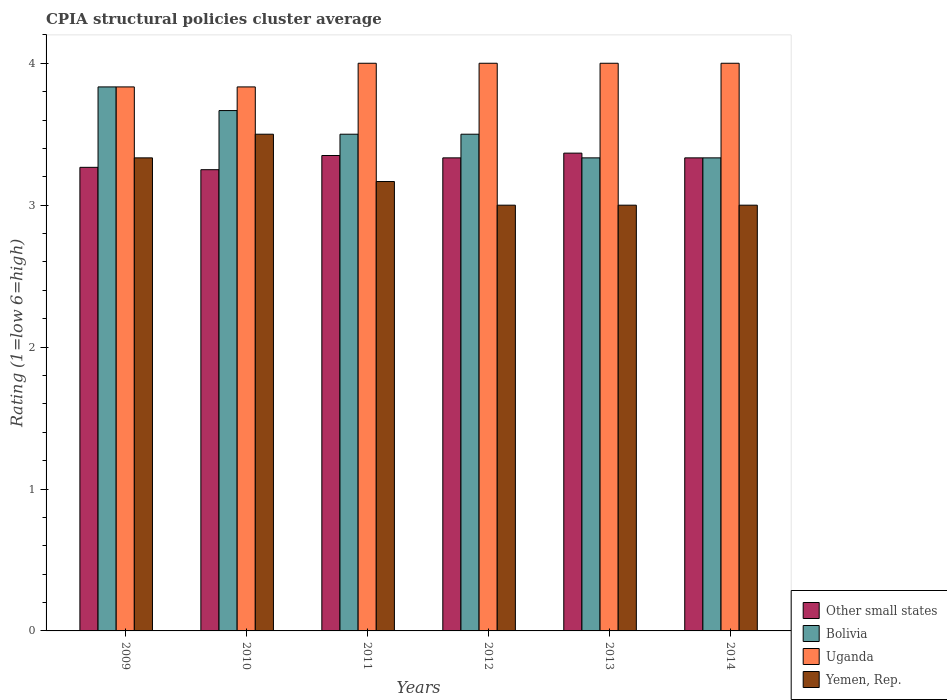How many different coloured bars are there?
Offer a very short reply. 4. Are the number of bars on each tick of the X-axis equal?
Your response must be concise. Yes. How many bars are there on the 1st tick from the right?
Offer a terse response. 4. What is the label of the 4th group of bars from the left?
Keep it short and to the point. 2012. In how many cases, is the number of bars for a given year not equal to the number of legend labels?
Provide a short and direct response. 0. What is the CPIA rating in Uganda in 2014?
Your answer should be compact. 4. Across all years, what is the maximum CPIA rating in Other small states?
Keep it short and to the point. 3.37. Across all years, what is the minimum CPIA rating in Bolivia?
Your answer should be very brief. 3.33. In which year was the CPIA rating in Bolivia minimum?
Offer a very short reply. 2014. What is the total CPIA rating in Uganda in the graph?
Your response must be concise. 23.67. What is the difference between the CPIA rating in Bolivia in 2011 and that in 2013?
Provide a succinct answer. 0.17. What is the difference between the CPIA rating in Uganda in 2010 and the CPIA rating in Yemen, Rep. in 2014?
Make the answer very short. 0.83. What is the average CPIA rating in Uganda per year?
Provide a short and direct response. 3.94. In the year 2009, what is the difference between the CPIA rating in Uganda and CPIA rating in Other small states?
Offer a terse response. 0.57. What is the ratio of the CPIA rating in Bolivia in 2009 to that in 2010?
Keep it short and to the point. 1.05. Is the CPIA rating in Other small states in 2011 less than that in 2012?
Offer a terse response. No. Is the difference between the CPIA rating in Uganda in 2010 and 2014 greater than the difference between the CPIA rating in Other small states in 2010 and 2014?
Offer a very short reply. No. In how many years, is the CPIA rating in Yemen, Rep. greater than the average CPIA rating in Yemen, Rep. taken over all years?
Ensure brevity in your answer.  3. Is it the case that in every year, the sum of the CPIA rating in Other small states and CPIA rating in Uganda is greater than the sum of CPIA rating in Yemen, Rep. and CPIA rating in Bolivia?
Your answer should be compact. Yes. What does the 4th bar from the right in 2014 represents?
Make the answer very short. Other small states. How many bars are there?
Ensure brevity in your answer.  24. How are the legend labels stacked?
Give a very brief answer. Vertical. What is the title of the graph?
Ensure brevity in your answer.  CPIA structural policies cluster average. Does "Faeroe Islands" appear as one of the legend labels in the graph?
Make the answer very short. No. What is the label or title of the X-axis?
Make the answer very short. Years. What is the label or title of the Y-axis?
Give a very brief answer. Rating (1=low 6=high). What is the Rating (1=low 6=high) in Other small states in 2009?
Your answer should be very brief. 3.27. What is the Rating (1=low 6=high) of Bolivia in 2009?
Your answer should be compact. 3.83. What is the Rating (1=low 6=high) in Uganda in 2009?
Your response must be concise. 3.83. What is the Rating (1=low 6=high) of Yemen, Rep. in 2009?
Offer a very short reply. 3.33. What is the Rating (1=low 6=high) in Other small states in 2010?
Ensure brevity in your answer.  3.25. What is the Rating (1=low 6=high) in Bolivia in 2010?
Keep it short and to the point. 3.67. What is the Rating (1=low 6=high) of Uganda in 2010?
Make the answer very short. 3.83. What is the Rating (1=low 6=high) of Other small states in 2011?
Your answer should be very brief. 3.35. What is the Rating (1=low 6=high) in Yemen, Rep. in 2011?
Offer a terse response. 3.17. What is the Rating (1=low 6=high) of Other small states in 2012?
Provide a succinct answer. 3.33. What is the Rating (1=low 6=high) in Other small states in 2013?
Offer a very short reply. 3.37. What is the Rating (1=low 6=high) of Bolivia in 2013?
Give a very brief answer. 3.33. What is the Rating (1=low 6=high) of Yemen, Rep. in 2013?
Make the answer very short. 3. What is the Rating (1=low 6=high) in Other small states in 2014?
Ensure brevity in your answer.  3.33. What is the Rating (1=low 6=high) of Bolivia in 2014?
Your answer should be compact. 3.33. What is the Rating (1=low 6=high) in Yemen, Rep. in 2014?
Provide a succinct answer. 3. Across all years, what is the maximum Rating (1=low 6=high) in Other small states?
Make the answer very short. 3.37. Across all years, what is the maximum Rating (1=low 6=high) in Bolivia?
Ensure brevity in your answer.  3.83. Across all years, what is the maximum Rating (1=low 6=high) of Yemen, Rep.?
Your answer should be very brief. 3.5. Across all years, what is the minimum Rating (1=low 6=high) in Other small states?
Ensure brevity in your answer.  3.25. Across all years, what is the minimum Rating (1=low 6=high) in Bolivia?
Ensure brevity in your answer.  3.33. Across all years, what is the minimum Rating (1=low 6=high) in Uganda?
Your response must be concise. 3.83. What is the total Rating (1=low 6=high) of Bolivia in the graph?
Offer a very short reply. 21.17. What is the total Rating (1=low 6=high) of Uganda in the graph?
Keep it short and to the point. 23.67. What is the total Rating (1=low 6=high) in Yemen, Rep. in the graph?
Offer a very short reply. 19. What is the difference between the Rating (1=low 6=high) in Other small states in 2009 and that in 2010?
Keep it short and to the point. 0.02. What is the difference between the Rating (1=low 6=high) of Bolivia in 2009 and that in 2010?
Your answer should be very brief. 0.17. What is the difference between the Rating (1=low 6=high) of Uganda in 2009 and that in 2010?
Ensure brevity in your answer.  0. What is the difference between the Rating (1=low 6=high) in Other small states in 2009 and that in 2011?
Provide a succinct answer. -0.08. What is the difference between the Rating (1=low 6=high) in Yemen, Rep. in 2009 and that in 2011?
Your answer should be very brief. 0.17. What is the difference between the Rating (1=low 6=high) of Other small states in 2009 and that in 2012?
Make the answer very short. -0.07. What is the difference between the Rating (1=low 6=high) of Bolivia in 2009 and that in 2012?
Make the answer very short. 0.33. What is the difference between the Rating (1=low 6=high) in Other small states in 2009 and that in 2013?
Keep it short and to the point. -0.1. What is the difference between the Rating (1=low 6=high) in Yemen, Rep. in 2009 and that in 2013?
Your answer should be very brief. 0.33. What is the difference between the Rating (1=low 6=high) of Other small states in 2009 and that in 2014?
Your answer should be compact. -0.07. What is the difference between the Rating (1=low 6=high) of Bolivia in 2010 and that in 2011?
Offer a very short reply. 0.17. What is the difference between the Rating (1=low 6=high) of Uganda in 2010 and that in 2011?
Make the answer very short. -0.17. What is the difference between the Rating (1=low 6=high) of Other small states in 2010 and that in 2012?
Give a very brief answer. -0.08. What is the difference between the Rating (1=low 6=high) in Uganda in 2010 and that in 2012?
Keep it short and to the point. -0.17. What is the difference between the Rating (1=low 6=high) of Other small states in 2010 and that in 2013?
Give a very brief answer. -0.12. What is the difference between the Rating (1=low 6=high) of Other small states in 2010 and that in 2014?
Offer a terse response. -0.08. What is the difference between the Rating (1=low 6=high) in Uganda in 2010 and that in 2014?
Offer a terse response. -0.17. What is the difference between the Rating (1=low 6=high) in Yemen, Rep. in 2010 and that in 2014?
Offer a very short reply. 0.5. What is the difference between the Rating (1=low 6=high) in Other small states in 2011 and that in 2012?
Ensure brevity in your answer.  0.02. What is the difference between the Rating (1=low 6=high) of Bolivia in 2011 and that in 2012?
Your response must be concise. 0. What is the difference between the Rating (1=low 6=high) of Uganda in 2011 and that in 2012?
Provide a short and direct response. 0. What is the difference between the Rating (1=low 6=high) in Yemen, Rep. in 2011 and that in 2012?
Make the answer very short. 0.17. What is the difference between the Rating (1=low 6=high) in Other small states in 2011 and that in 2013?
Provide a succinct answer. -0.02. What is the difference between the Rating (1=low 6=high) of Bolivia in 2011 and that in 2013?
Your response must be concise. 0.17. What is the difference between the Rating (1=low 6=high) of Uganda in 2011 and that in 2013?
Offer a very short reply. 0. What is the difference between the Rating (1=low 6=high) in Yemen, Rep. in 2011 and that in 2013?
Provide a succinct answer. 0.17. What is the difference between the Rating (1=low 6=high) in Other small states in 2011 and that in 2014?
Your response must be concise. 0.02. What is the difference between the Rating (1=low 6=high) of Uganda in 2011 and that in 2014?
Offer a very short reply. 0. What is the difference between the Rating (1=low 6=high) of Yemen, Rep. in 2011 and that in 2014?
Your response must be concise. 0.17. What is the difference between the Rating (1=low 6=high) in Other small states in 2012 and that in 2013?
Make the answer very short. -0.03. What is the difference between the Rating (1=low 6=high) in Bolivia in 2012 and that in 2013?
Offer a very short reply. 0.17. What is the difference between the Rating (1=low 6=high) of Other small states in 2012 and that in 2014?
Ensure brevity in your answer.  0. What is the difference between the Rating (1=low 6=high) in Uganda in 2012 and that in 2014?
Your response must be concise. 0. What is the difference between the Rating (1=low 6=high) of Yemen, Rep. in 2012 and that in 2014?
Your response must be concise. 0. What is the difference between the Rating (1=low 6=high) in Bolivia in 2013 and that in 2014?
Your answer should be compact. 0. What is the difference between the Rating (1=low 6=high) in Uganda in 2013 and that in 2014?
Offer a very short reply. 0. What is the difference between the Rating (1=low 6=high) of Yemen, Rep. in 2013 and that in 2014?
Ensure brevity in your answer.  0. What is the difference between the Rating (1=low 6=high) in Other small states in 2009 and the Rating (1=low 6=high) in Bolivia in 2010?
Provide a short and direct response. -0.4. What is the difference between the Rating (1=low 6=high) of Other small states in 2009 and the Rating (1=low 6=high) of Uganda in 2010?
Your response must be concise. -0.57. What is the difference between the Rating (1=low 6=high) in Other small states in 2009 and the Rating (1=low 6=high) in Yemen, Rep. in 2010?
Ensure brevity in your answer.  -0.23. What is the difference between the Rating (1=low 6=high) in Bolivia in 2009 and the Rating (1=low 6=high) in Uganda in 2010?
Make the answer very short. 0. What is the difference between the Rating (1=low 6=high) in Other small states in 2009 and the Rating (1=low 6=high) in Bolivia in 2011?
Ensure brevity in your answer.  -0.23. What is the difference between the Rating (1=low 6=high) in Other small states in 2009 and the Rating (1=low 6=high) in Uganda in 2011?
Make the answer very short. -0.73. What is the difference between the Rating (1=low 6=high) in Bolivia in 2009 and the Rating (1=low 6=high) in Yemen, Rep. in 2011?
Provide a short and direct response. 0.67. What is the difference between the Rating (1=low 6=high) in Uganda in 2009 and the Rating (1=low 6=high) in Yemen, Rep. in 2011?
Offer a terse response. 0.67. What is the difference between the Rating (1=low 6=high) in Other small states in 2009 and the Rating (1=low 6=high) in Bolivia in 2012?
Ensure brevity in your answer.  -0.23. What is the difference between the Rating (1=low 6=high) in Other small states in 2009 and the Rating (1=low 6=high) in Uganda in 2012?
Your response must be concise. -0.73. What is the difference between the Rating (1=low 6=high) of Other small states in 2009 and the Rating (1=low 6=high) of Yemen, Rep. in 2012?
Your response must be concise. 0.27. What is the difference between the Rating (1=low 6=high) in Bolivia in 2009 and the Rating (1=low 6=high) in Uganda in 2012?
Offer a very short reply. -0.17. What is the difference between the Rating (1=low 6=high) of Bolivia in 2009 and the Rating (1=low 6=high) of Yemen, Rep. in 2012?
Make the answer very short. 0.83. What is the difference between the Rating (1=low 6=high) in Uganda in 2009 and the Rating (1=low 6=high) in Yemen, Rep. in 2012?
Provide a short and direct response. 0.83. What is the difference between the Rating (1=low 6=high) in Other small states in 2009 and the Rating (1=low 6=high) in Bolivia in 2013?
Provide a succinct answer. -0.07. What is the difference between the Rating (1=low 6=high) of Other small states in 2009 and the Rating (1=low 6=high) of Uganda in 2013?
Ensure brevity in your answer.  -0.73. What is the difference between the Rating (1=low 6=high) of Other small states in 2009 and the Rating (1=low 6=high) of Yemen, Rep. in 2013?
Give a very brief answer. 0.27. What is the difference between the Rating (1=low 6=high) of Uganda in 2009 and the Rating (1=low 6=high) of Yemen, Rep. in 2013?
Give a very brief answer. 0.83. What is the difference between the Rating (1=low 6=high) of Other small states in 2009 and the Rating (1=low 6=high) of Bolivia in 2014?
Your answer should be compact. -0.07. What is the difference between the Rating (1=low 6=high) of Other small states in 2009 and the Rating (1=low 6=high) of Uganda in 2014?
Ensure brevity in your answer.  -0.73. What is the difference between the Rating (1=low 6=high) in Other small states in 2009 and the Rating (1=low 6=high) in Yemen, Rep. in 2014?
Offer a very short reply. 0.27. What is the difference between the Rating (1=low 6=high) in Uganda in 2009 and the Rating (1=low 6=high) in Yemen, Rep. in 2014?
Provide a short and direct response. 0.83. What is the difference between the Rating (1=low 6=high) in Other small states in 2010 and the Rating (1=low 6=high) in Uganda in 2011?
Your answer should be very brief. -0.75. What is the difference between the Rating (1=low 6=high) of Other small states in 2010 and the Rating (1=low 6=high) of Yemen, Rep. in 2011?
Your response must be concise. 0.08. What is the difference between the Rating (1=low 6=high) of Bolivia in 2010 and the Rating (1=low 6=high) of Uganda in 2011?
Your response must be concise. -0.33. What is the difference between the Rating (1=low 6=high) of Bolivia in 2010 and the Rating (1=low 6=high) of Yemen, Rep. in 2011?
Provide a short and direct response. 0.5. What is the difference between the Rating (1=low 6=high) of Other small states in 2010 and the Rating (1=low 6=high) of Uganda in 2012?
Your answer should be very brief. -0.75. What is the difference between the Rating (1=low 6=high) in Other small states in 2010 and the Rating (1=low 6=high) in Yemen, Rep. in 2012?
Keep it short and to the point. 0.25. What is the difference between the Rating (1=low 6=high) of Bolivia in 2010 and the Rating (1=low 6=high) of Uganda in 2012?
Your response must be concise. -0.33. What is the difference between the Rating (1=low 6=high) of Bolivia in 2010 and the Rating (1=low 6=high) of Yemen, Rep. in 2012?
Provide a succinct answer. 0.67. What is the difference between the Rating (1=low 6=high) in Other small states in 2010 and the Rating (1=low 6=high) in Bolivia in 2013?
Ensure brevity in your answer.  -0.08. What is the difference between the Rating (1=low 6=high) of Other small states in 2010 and the Rating (1=low 6=high) of Uganda in 2013?
Your answer should be compact. -0.75. What is the difference between the Rating (1=low 6=high) of Other small states in 2010 and the Rating (1=low 6=high) of Yemen, Rep. in 2013?
Your answer should be very brief. 0.25. What is the difference between the Rating (1=low 6=high) in Other small states in 2010 and the Rating (1=low 6=high) in Bolivia in 2014?
Keep it short and to the point. -0.08. What is the difference between the Rating (1=low 6=high) of Other small states in 2010 and the Rating (1=low 6=high) of Uganda in 2014?
Give a very brief answer. -0.75. What is the difference between the Rating (1=low 6=high) in Other small states in 2010 and the Rating (1=low 6=high) in Yemen, Rep. in 2014?
Provide a short and direct response. 0.25. What is the difference between the Rating (1=low 6=high) in Bolivia in 2010 and the Rating (1=low 6=high) in Uganda in 2014?
Your answer should be very brief. -0.33. What is the difference between the Rating (1=low 6=high) in Other small states in 2011 and the Rating (1=low 6=high) in Bolivia in 2012?
Provide a succinct answer. -0.15. What is the difference between the Rating (1=low 6=high) of Other small states in 2011 and the Rating (1=low 6=high) of Uganda in 2012?
Provide a short and direct response. -0.65. What is the difference between the Rating (1=low 6=high) in Other small states in 2011 and the Rating (1=low 6=high) in Yemen, Rep. in 2012?
Make the answer very short. 0.35. What is the difference between the Rating (1=low 6=high) in Bolivia in 2011 and the Rating (1=low 6=high) in Uganda in 2012?
Keep it short and to the point. -0.5. What is the difference between the Rating (1=low 6=high) in Bolivia in 2011 and the Rating (1=low 6=high) in Yemen, Rep. in 2012?
Offer a terse response. 0.5. What is the difference between the Rating (1=low 6=high) of Uganda in 2011 and the Rating (1=low 6=high) of Yemen, Rep. in 2012?
Provide a succinct answer. 1. What is the difference between the Rating (1=low 6=high) of Other small states in 2011 and the Rating (1=low 6=high) of Bolivia in 2013?
Offer a very short reply. 0.02. What is the difference between the Rating (1=low 6=high) of Other small states in 2011 and the Rating (1=low 6=high) of Uganda in 2013?
Your response must be concise. -0.65. What is the difference between the Rating (1=low 6=high) in Other small states in 2011 and the Rating (1=low 6=high) in Bolivia in 2014?
Your answer should be compact. 0.02. What is the difference between the Rating (1=low 6=high) of Other small states in 2011 and the Rating (1=low 6=high) of Uganda in 2014?
Your response must be concise. -0.65. What is the difference between the Rating (1=low 6=high) of Uganda in 2011 and the Rating (1=low 6=high) of Yemen, Rep. in 2014?
Your response must be concise. 1. What is the difference between the Rating (1=low 6=high) in Other small states in 2012 and the Rating (1=low 6=high) in Yemen, Rep. in 2013?
Your answer should be very brief. 0.33. What is the difference between the Rating (1=low 6=high) of Bolivia in 2012 and the Rating (1=low 6=high) of Uganda in 2013?
Offer a terse response. -0.5. What is the difference between the Rating (1=low 6=high) of Bolivia in 2012 and the Rating (1=low 6=high) of Yemen, Rep. in 2013?
Make the answer very short. 0.5. What is the difference between the Rating (1=low 6=high) in Uganda in 2012 and the Rating (1=low 6=high) in Yemen, Rep. in 2013?
Offer a terse response. 1. What is the difference between the Rating (1=low 6=high) in Other small states in 2012 and the Rating (1=low 6=high) in Bolivia in 2014?
Offer a terse response. 0. What is the difference between the Rating (1=low 6=high) of Other small states in 2012 and the Rating (1=low 6=high) of Uganda in 2014?
Provide a succinct answer. -0.67. What is the difference between the Rating (1=low 6=high) in Bolivia in 2012 and the Rating (1=low 6=high) in Yemen, Rep. in 2014?
Give a very brief answer. 0.5. What is the difference between the Rating (1=low 6=high) in Other small states in 2013 and the Rating (1=low 6=high) in Uganda in 2014?
Give a very brief answer. -0.63. What is the difference between the Rating (1=low 6=high) in Other small states in 2013 and the Rating (1=low 6=high) in Yemen, Rep. in 2014?
Provide a short and direct response. 0.37. What is the difference between the Rating (1=low 6=high) in Bolivia in 2013 and the Rating (1=low 6=high) in Uganda in 2014?
Provide a succinct answer. -0.67. What is the difference between the Rating (1=low 6=high) of Bolivia in 2013 and the Rating (1=low 6=high) of Yemen, Rep. in 2014?
Your answer should be very brief. 0.33. What is the difference between the Rating (1=low 6=high) of Uganda in 2013 and the Rating (1=low 6=high) of Yemen, Rep. in 2014?
Make the answer very short. 1. What is the average Rating (1=low 6=high) of Other small states per year?
Your response must be concise. 3.32. What is the average Rating (1=low 6=high) of Bolivia per year?
Make the answer very short. 3.53. What is the average Rating (1=low 6=high) in Uganda per year?
Make the answer very short. 3.94. What is the average Rating (1=low 6=high) of Yemen, Rep. per year?
Ensure brevity in your answer.  3.17. In the year 2009, what is the difference between the Rating (1=low 6=high) of Other small states and Rating (1=low 6=high) of Bolivia?
Make the answer very short. -0.57. In the year 2009, what is the difference between the Rating (1=low 6=high) of Other small states and Rating (1=low 6=high) of Uganda?
Offer a terse response. -0.57. In the year 2009, what is the difference between the Rating (1=low 6=high) in Other small states and Rating (1=low 6=high) in Yemen, Rep.?
Give a very brief answer. -0.07. In the year 2009, what is the difference between the Rating (1=low 6=high) in Uganda and Rating (1=low 6=high) in Yemen, Rep.?
Offer a terse response. 0.5. In the year 2010, what is the difference between the Rating (1=low 6=high) of Other small states and Rating (1=low 6=high) of Bolivia?
Ensure brevity in your answer.  -0.42. In the year 2010, what is the difference between the Rating (1=low 6=high) of Other small states and Rating (1=low 6=high) of Uganda?
Provide a short and direct response. -0.58. In the year 2010, what is the difference between the Rating (1=low 6=high) in Uganda and Rating (1=low 6=high) in Yemen, Rep.?
Make the answer very short. 0.33. In the year 2011, what is the difference between the Rating (1=low 6=high) of Other small states and Rating (1=low 6=high) of Uganda?
Your response must be concise. -0.65. In the year 2011, what is the difference between the Rating (1=low 6=high) in Other small states and Rating (1=low 6=high) in Yemen, Rep.?
Provide a short and direct response. 0.18. In the year 2011, what is the difference between the Rating (1=low 6=high) in Bolivia and Rating (1=low 6=high) in Uganda?
Offer a terse response. -0.5. In the year 2011, what is the difference between the Rating (1=low 6=high) of Bolivia and Rating (1=low 6=high) of Yemen, Rep.?
Your response must be concise. 0.33. In the year 2011, what is the difference between the Rating (1=low 6=high) in Uganda and Rating (1=low 6=high) in Yemen, Rep.?
Keep it short and to the point. 0.83. In the year 2012, what is the difference between the Rating (1=low 6=high) in Other small states and Rating (1=low 6=high) in Uganda?
Ensure brevity in your answer.  -0.67. In the year 2012, what is the difference between the Rating (1=low 6=high) of Bolivia and Rating (1=low 6=high) of Yemen, Rep.?
Your response must be concise. 0.5. In the year 2012, what is the difference between the Rating (1=low 6=high) in Uganda and Rating (1=low 6=high) in Yemen, Rep.?
Keep it short and to the point. 1. In the year 2013, what is the difference between the Rating (1=low 6=high) of Other small states and Rating (1=low 6=high) of Uganda?
Your answer should be compact. -0.63. In the year 2013, what is the difference between the Rating (1=low 6=high) of Other small states and Rating (1=low 6=high) of Yemen, Rep.?
Provide a succinct answer. 0.37. In the year 2013, what is the difference between the Rating (1=low 6=high) in Uganda and Rating (1=low 6=high) in Yemen, Rep.?
Your answer should be compact. 1. In the year 2014, what is the difference between the Rating (1=low 6=high) of Other small states and Rating (1=low 6=high) of Bolivia?
Your answer should be compact. 0. In the year 2014, what is the difference between the Rating (1=low 6=high) in Other small states and Rating (1=low 6=high) in Yemen, Rep.?
Give a very brief answer. 0.33. In the year 2014, what is the difference between the Rating (1=low 6=high) of Bolivia and Rating (1=low 6=high) of Yemen, Rep.?
Your answer should be very brief. 0.33. What is the ratio of the Rating (1=low 6=high) of Other small states in 2009 to that in 2010?
Give a very brief answer. 1.01. What is the ratio of the Rating (1=low 6=high) in Bolivia in 2009 to that in 2010?
Provide a short and direct response. 1.05. What is the ratio of the Rating (1=low 6=high) in Other small states in 2009 to that in 2011?
Your answer should be compact. 0.98. What is the ratio of the Rating (1=low 6=high) of Bolivia in 2009 to that in 2011?
Ensure brevity in your answer.  1.1. What is the ratio of the Rating (1=low 6=high) of Yemen, Rep. in 2009 to that in 2011?
Your answer should be very brief. 1.05. What is the ratio of the Rating (1=low 6=high) in Other small states in 2009 to that in 2012?
Make the answer very short. 0.98. What is the ratio of the Rating (1=low 6=high) of Bolivia in 2009 to that in 2012?
Offer a very short reply. 1.1. What is the ratio of the Rating (1=low 6=high) in Yemen, Rep. in 2009 to that in 2012?
Provide a succinct answer. 1.11. What is the ratio of the Rating (1=low 6=high) in Other small states in 2009 to that in 2013?
Your answer should be very brief. 0.97. What is the ratio of the Rating (1=low 6=high) of Bolivia in 2009 to that in 2013?
Provide a short and direct response. 1.15. What is the ratio of the Rating (1=low 6=high) of Uganda in 2009 to that in 2013?
Offer a very short reply. 0.96. What is the ratio of the Rating (1=low 6=high) of Yemen, Rep. in 2009 to that in 2013?
Provide a short and direct response. 1.11. What is the ratio of the Rating (1=low 6=high) of Other small states in 2009 to that in 2014?
Provide a short and direct response. 0.98. What is the ratio of the Rating (1=low 6=high) in Bolivia in 2009 to that in 2014?
Give a very brief answer. 1.15. What is the ratio of the Rating (1=low 6=high) of Uganda in 2009 to that in 2014?
Make the answer very short. 0.96. What is the ratio of the Rating (1=low 6=high) of Yemen, Rep. in 2009 to that in 2014?
Your answer should be compact. 1.11. What is the ratio of the Rating (1=low 6=high) of Other small states in 2010 to that in 2011?
Offer a very short reply. 0.97. What is the ratio of the Rating (1=low 6=high) in Bolivia in 2010 to that in 2011?
Offer a terse response. 1.05. What is the ratio of the Rating (1=low 6=high) in Yemen, Rep. in 2010 to that in 2011?
Your answer should be very brief. 1.11. What is the ratio of the Rating (1=low 6=high) in Bolivia in 2010 to that in 2012?
Your response must be concise. 1.05. What is the ratio of the Rating (1=low 6=high) of Other small states in 2010 to that in 2013?
Your answer should be very brief. 0.97. What is the ratio of the Rating (1=low 6=high) in Bolivia in 2010 to that in 2013?
Offer a very short reply. 1.1. What is the ratio of the Rating (1=low 6=high) of Uganda in 2010 to that in 2013?
Ensure brevity in your answer.  0.96. What is the ratio of the Rating (1=low 6=high) in Uganda in 2010 to that in 2014?
Provide a short and direct response. 0.96. What is the ratio of the Rating (1=low 6=high) in Uganda in 2011 to that in 2012?
Give a very brief answer. 1. What is the ratio of the Rating (1=low 6=high) of Yemen, Rep. in 2011 to that in 2012?
Provide a short and direct response. 1.06. What is the ratio of the Rating (1=low 6=high) in Bolivia in 2011 to that in 2013?
Offer a terse response. 1.05. What is the ratio of the Rating (1=low 6=high) of Yemen, Rep. in 2011 to that in 2013?
Your answer should be very brief. 1.06. What is the ratio of the Rating (1=low 6=high) in Other small states in 2011 to that in 2014?
Keep it short and to the point. 1. What is the ratio of the Rating (1=low 6=high) in Yemen, Rep. in 2011 to that in 2014?
Your answer should be very brief. 1.06. What is the ratio of the Rating (1=low 6=high) in Bolivia in 2012 to that in 2013?
Offer a terse response. 1.05. What is the ratio of the Rating (1=low 6=high) in Yemen, Rep. in 2012 to that in 2013?
Keep it short and to the point. 1. What is the ratio of the Rating (1=low 6=high) of Bolivia in 2012 to that in 2014?
Offer a very short reply. 1.05. What is the ratio of the Rating (1=low 6=high) of Yemen, Rep. in 2012 to that in 2014?
Offer a terse response. 1. What is the ratio of the Rating (1=low 6=high) of Other small states in 2013 to that in 2014?
Give a very brief answer. 1.01. What is the ratio of the Rating (1=low 6=high) of Yemen, Rep. in 2013 to that in 2014?
Keep it short and to the point. 1. What is the difference between the highest and the second highest Rating (1=low 6=high) in Other small states?
Ensure brevity in your answer.  0.02. What is the difference between the highest and the second highest Rating (1=low 6=high) in Bolivia?
Make the answer very short. 0.17. What is the difference between the highest and the second highest Rating (1=low 6=high) in Uganda?
Give a very brief answer. 0. What is the difference between the highest and the lowest Rating (1=low 6=high) in Other small states?
Give a very brief answer. 0.12. What is the difference between the highest and the lowest Rating (1=low 6=high) in Bolivia?
Offer a terse response. 0.5. What is the difference between the highest and the lowest Rating (1=low 6=high) in Uganda?
Offer a very short reply. 0.17. 